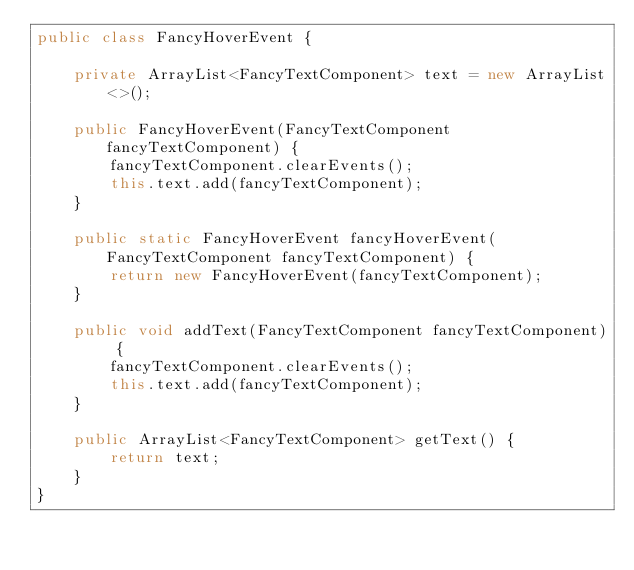<code> <loc_0><loc_0><loc_500><loc_500><_Java_>public class FancyHoverEvent {

    private ArrayList<FancyTextComponent> text = new ArrayList<>();

    public FancyHoverEvent(FancyTextComponent fancyTextComponent) {
        fancyTextComponent.clearEvents();
        this.text.add(fancyTextComponent);
    }

    public static FancyHoverEvent fancyHoverEvent(FancyTextComponent fancyTextComponent) {
        return new FancyHoverEvent(fancyTextComponent);
    }

    public void addText(FancyTextComponent fancyTextComponent) {
        fancyTextComponent.clearEvents();
        this.text.add(fancyTextComponent);
    }

    public ArrayList<FancyTextComponent> getText() {
        return text;
    }
}
</code> 